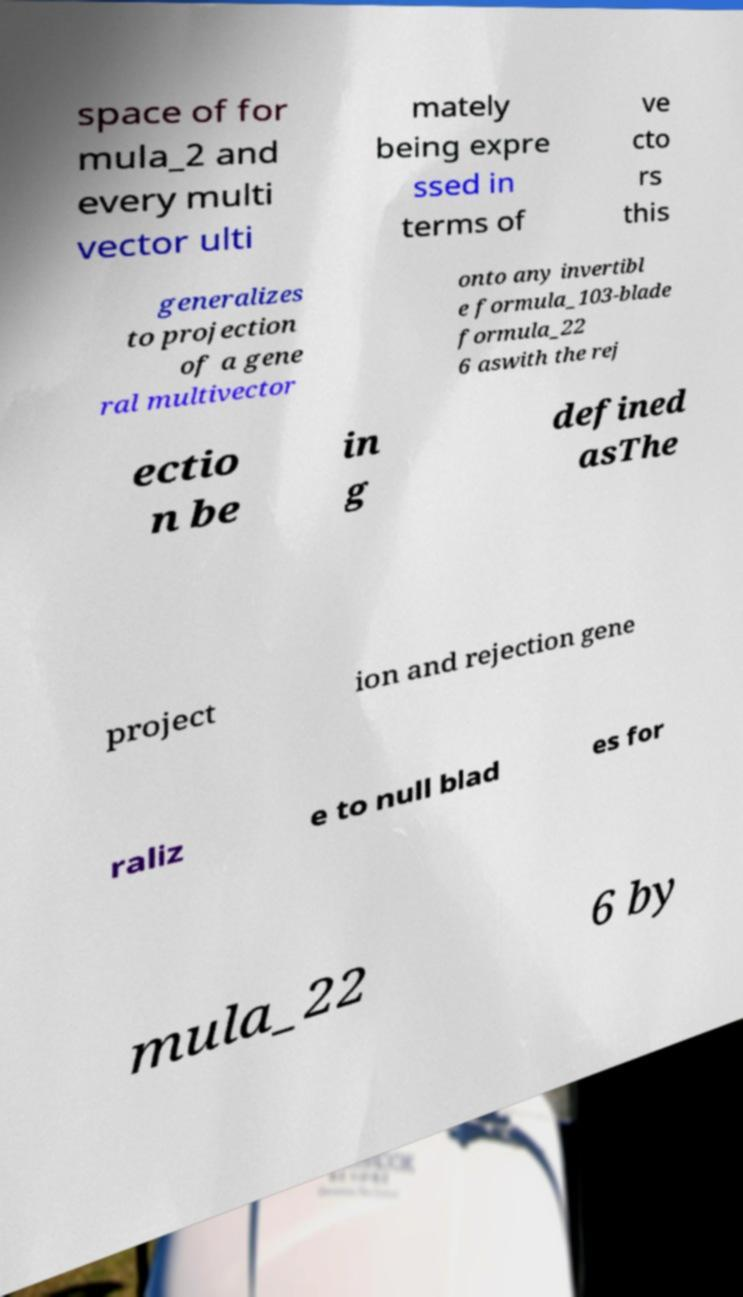I need the written content from this picture converted into text. Can you do that? space of for mula_2 and every multi vector ulti mately being expre ssed in terms of ve cto rs this generalizes to projection of a gene ral multivector onto any invertibl e formula_103-blade formula_22 6 aswith the rej ectio n be in g defined asThe project ion and rejection gene raliz e to null blad es for mula_22 6 by 